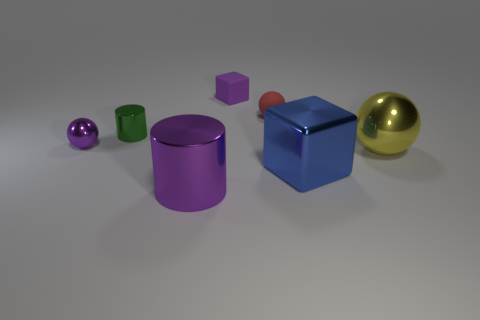Subtract all cylinders. How many objects are left? 5 Subtract 1 cubes. How many cubes are left? 1 Subtract all cyan cylinders. Subtract all green blocks. How many cylinders are left? 2 Subtract all brown spheres. How many green cylinders are left? 1 Subtract all yellow spheres. Subtract all small metal cylinders. How many objects are left? 5 Add 5 tiny rubber balls. How many tiny rubber balls are left? 6 Add 6 large yellow shiny objects. How many large yellow shiny objects exist? 7 Add 1 tiny gray shiny balls. How many objects exist? 8 Subtract all blue blocks. How many blocks are left? 1 Subtract all large yellow spheres. How many spheres are left? 2 